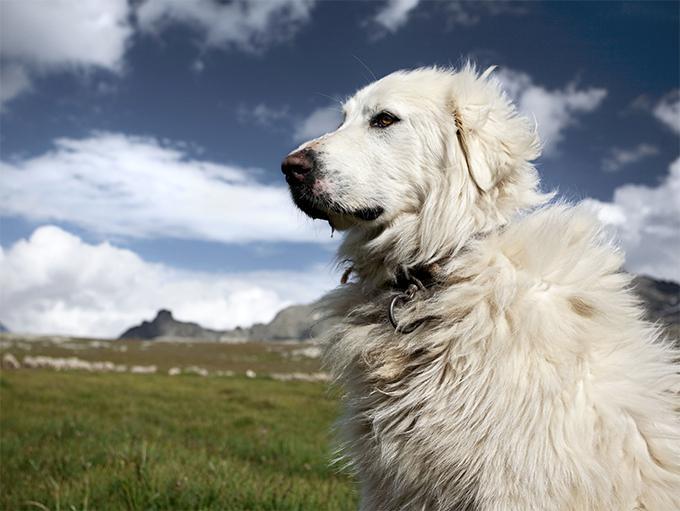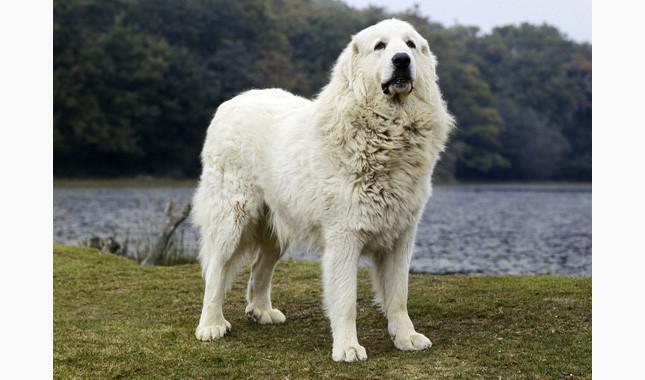The first image is the image on the left, the second image is the image on the right. For the images displayed, is the sentence "There is a dog laying in the grass next to another dog" factually correct? Answer yes or no. No. The first image is the image on the left, the second image is the image on the right. Assess this claim about the two images: "There are no more than two white dogs.". Correct or not? Answer yes or no. Yes. The first image is the image on the left, the second image is the image on the right. Analyze the images presented: Is the assertion "At least one dog in an image in the pair has its mouth open and tongue visible." valid? Answer yes or no. No. The first image is the image on the left, the second image is the image on the right. Analyze the images presented: Is the assertion "There are two dogs" valid? Answer yes or no. Yes. 